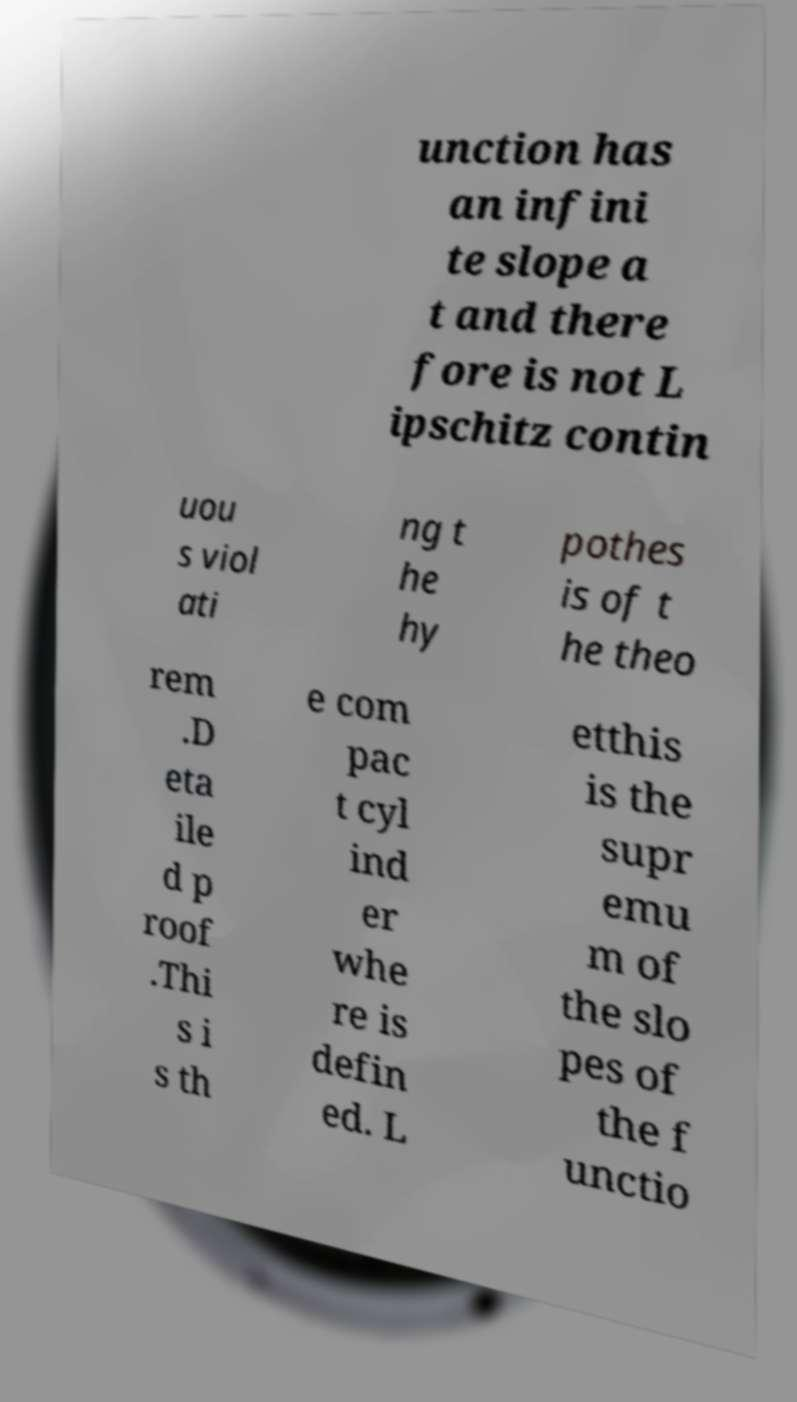Could you extract and type out the text from this image? unction has an infini te slope a t and there fore is not L ipschitz contin uou s viol ati ng t he hy pothes is of t he theo rem .D eta ile d p roof .Thi s i s th e com pac t cyl ind er whe re is defin ed. L etthis is the supr emu m of the slo pes of the f unctio 